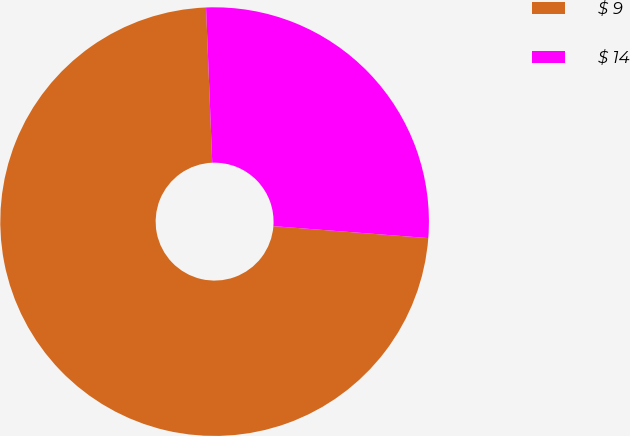<chart> <loc_0><loc_0><loc_500><loc_500><pie_chart><fcel>$ 9<fcel>$ 14<nl><fcel>73.14%<fcel>26.86%<nl></chart> 